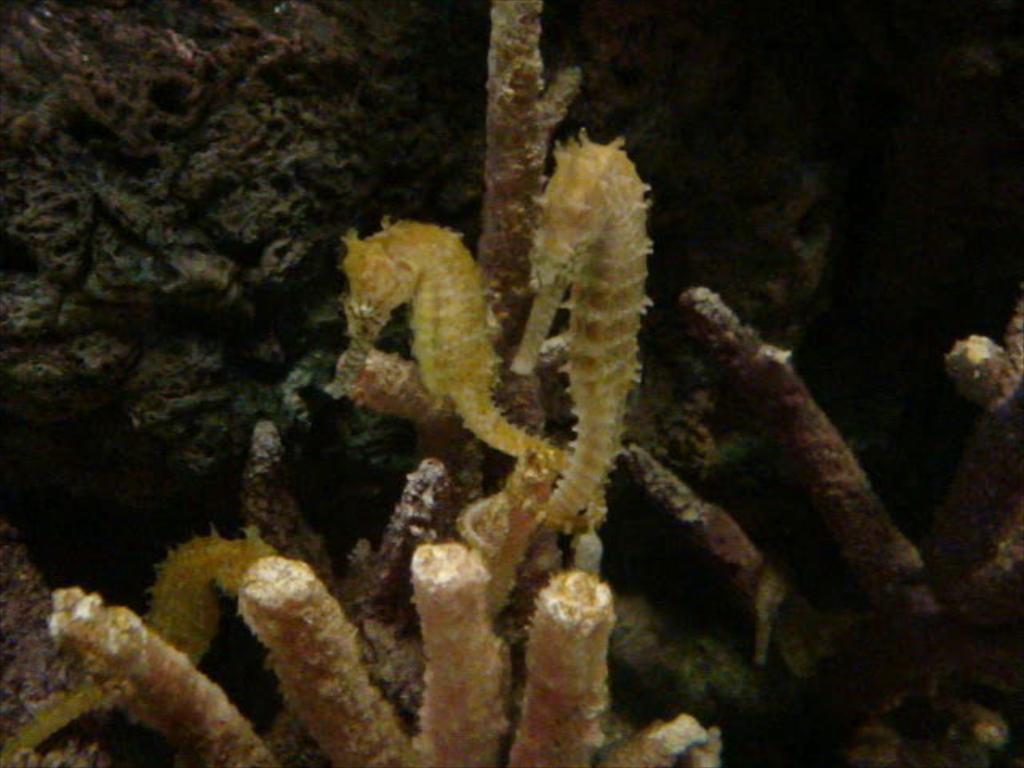Please provide a concise description of this image. In this image, we can see sea horses, corals and dark view. 